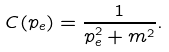Convert formula to latex. <formula><loc_0><loc_0><loc_500><loc_500>C ( p _ { e } ) = \frac { 1 } { p _ { e } ^ { 2 } + m ^ { 2 } } .</formula> 